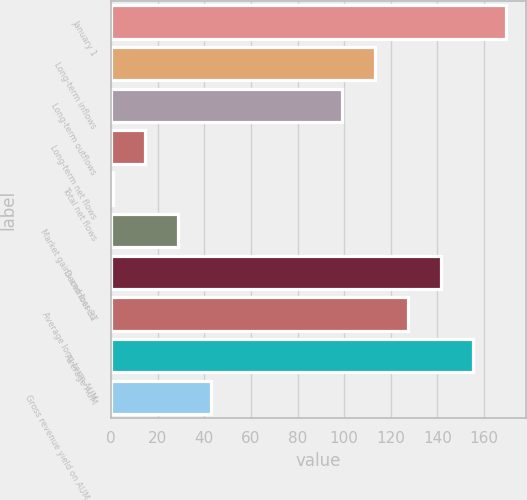<chart> <loc_0><loc_0><loc_500><loc_500><bar_chart><fcel>January 1<fcel>Long-term inflows<fcel>Long-term outflows<fcel>Long-term net flows<fcel>Total net flows<fcel>Market gains and losses/<fcel>December 31<fcel>Average long-term AUM<fcel>Average AUM<fcel>Gross revenue yield on AUM (2)<nl><fcel>169.54<fcel>113.26<fcel>99.19<fcel>14.77<fcel>0.7<fcel>28.84<fcel>141.4<fcel>127.33<fcel>155.47<fcel>42.91<nl></chart> 